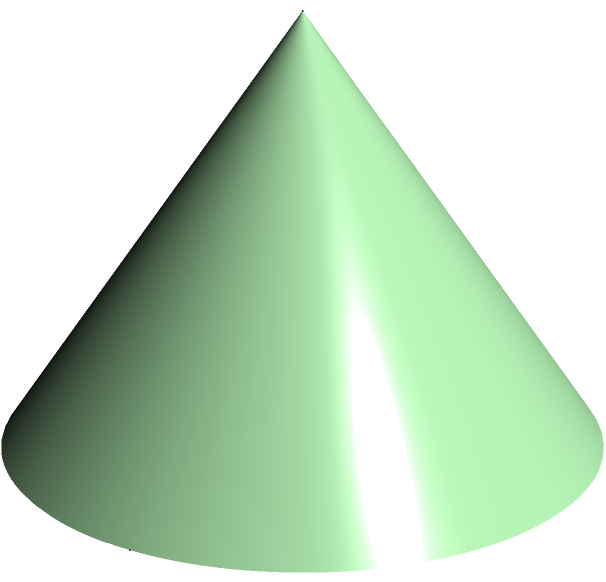As a mycologist studying the potential benefits of fungi in agriculture, you're analyzing the surface area of a conical mushroom cap. The cap has a radius of 3 cm at its base and a height of 4 cm. What is the surface area of the mushroom cap, excluding the base? Round your answer to the nearest square centimeter. Let's approach this step-by-step:

1) The surface area of a cone (excluding the base) is given by the formula:
   $$A = \pi r s$$
   where $r$ is the radius of the base and $s$ is the slant height.

2) We know the radius $r = 3$ cm and the height $h = 4$ cm, but we need to find the slant height $s$.

3) We can find $s$ using the Pythagorean theorem:
   $$s^2 = r^2 + h^2$$

4) Substituting the values:
   $$s^2 = 3^2 + 4^2 = 9 + 16 = 25$$

5) Taking the square root:
   $$s = \sqrt{25} = 5 \text{ cm}$$

6) Now we can calculate the surface area:
   $$A = \pi r s = \pi \cdot 3 \cdot 5 = 15\pi \text{ cm}^2$$

7) Calculating this:
   $$15\pi \approx 47.12 \text{ cm}^2$$

8) Rounding to the nearest square centimeter:
   $$47.12 \text{ cm}^2 \approx 47 \text{ cm}^2$$
Answer: 47 cm² 